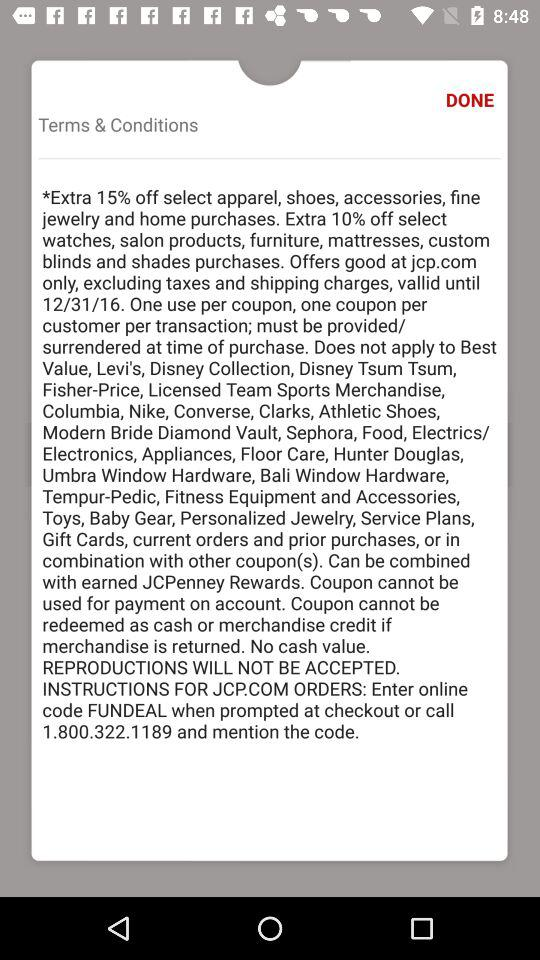How many percent off is the coupon for apparel, shoes, accessories, fine jewelry and home purchases?
Answer the question using a single word or phrase. 15% 